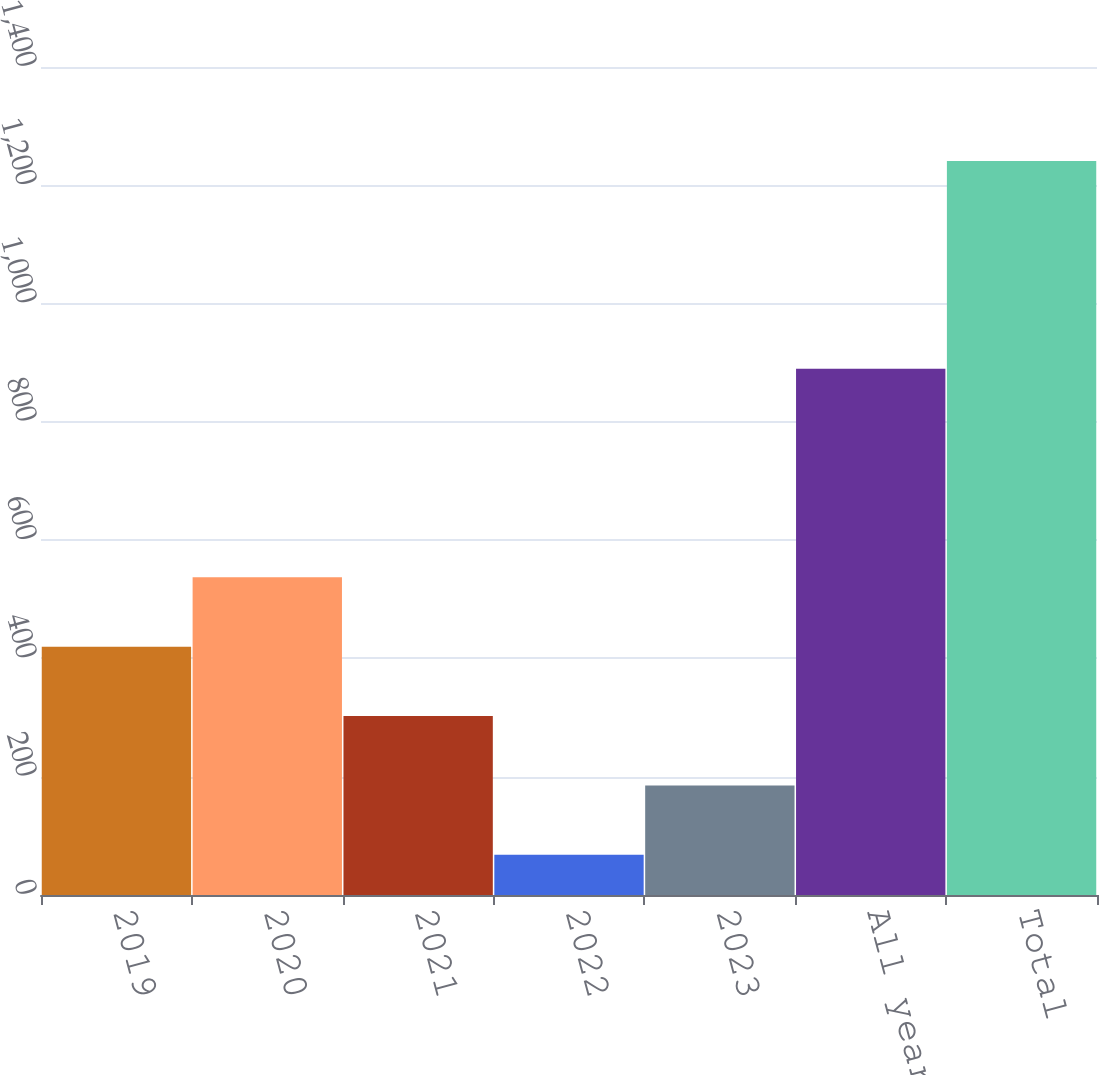Convert chart. <chart><loc_0><loc_0><loc_500><loc_500><bar_chart><fcel>2019<fcel>2020<fcel>2021<fcel>2022<fcel>2023<fcel>All years thereafter<fcel>Total<nl><fcel>419.9<fcel>537.2<fcel>302.6<fcel>68<fcel>185.3<fcel>890<fcel>1241<nl></chart> 